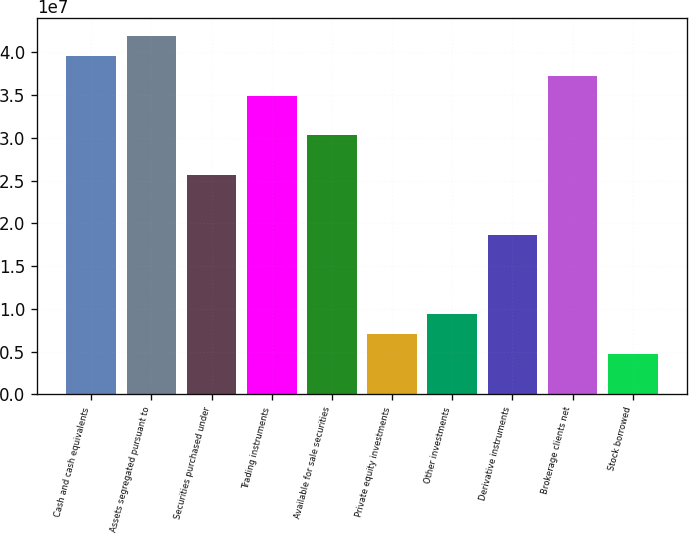Convert chart. <chart><loc_0><loc_0><loc_500><loc_500><bar_chart><fcel>Cash and cash equivalents<fcel>Assets segregated pursuant to<fcel>Securities purchased under<fcel>Trading instruments<fcel>Available for sale securities<fcel>Private equity investments<fcel>Other investments<fcel>Derivative instruments<fcel>Brokerage clients net<fcel>Stock borrowed<nl><fcel>3.95786e+07<fcel>4.19005e+07<fcel>2.56475e+07<fcel>3.49349e+07<fcel>3.02912e+07<fcel>7.07268e+06<fcel>9.39453e+06<fcel>1.86819e+07<fcel>3.72568e+07<fcel>4.75082e+06<nl></chart> 